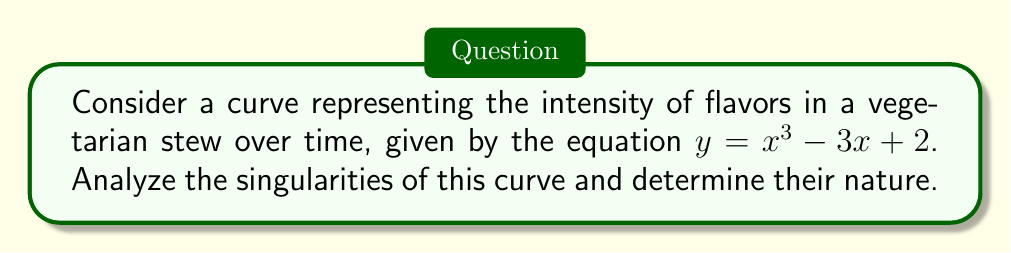Solve this math problem. To analyze the singularities of the curve $y = x^3 - 3x + 2$, we'll follow these steps:

1) First, we need to find the points where both $\frac{dy}{dx}$ and $\frac{d^2y}{dx^2}$ are zero.

2) Calculate $\frac{dy}{dx}$:
   $\frac{dy}{dx} = 3x^2 - 3$

3) Calculate $\frac{d^2y}{dx^2}$:
   $\frac{d^2y}{dx^2} = 6x$

4) Set $\frac{dy}{dx} = 0$ and solve for x:
   $3x^2 - 3 = 0$
   $3(x^2 - 1) = 0$
   $x^2 = 1$
   $x = \pm 1$

5) Now, we need to check these points $(1, 0)$ and $(-1, 0)$ to see if they are singularities.

6) At $x = 1$:
   $\frac{dy}{dx} = 3(1)^2 - 3 = 0$
   $\frac{d^2y}{dx^2} = 6(1) = 6 \neq 0$

7) At $x = -1$:
   $\frac{dy}{dx} = 3(-1)^2 - 3 = 0$
   $\frac{d^2y}{dx^2} = 6(-1) = -6 \neq 0$

8) Since $\frac{d^2y}{dx^2} \neq 0$ at both points, these are not singularities but rather stationary points.

9) The curve has no singularities. It has two stationary points at $(1, 0)$ and $(-1, 0)$, which represent local extrema in flavor intensity.

[asy]
import graph;
size(200,200);
real f(real x) {return x^3 - 3x + 2;}
draw(graph(f,-2,2));
dot((1,0));
dot((-1,0));
xaxis("x");
yaxis("y");
label("(1,0)",(1,0),E);
label("(-1,0)",(-1,0),W);
[/asy]
Answer: No singularities; two stationary points at $(1, 0)$ and $(-1, 0)$. 